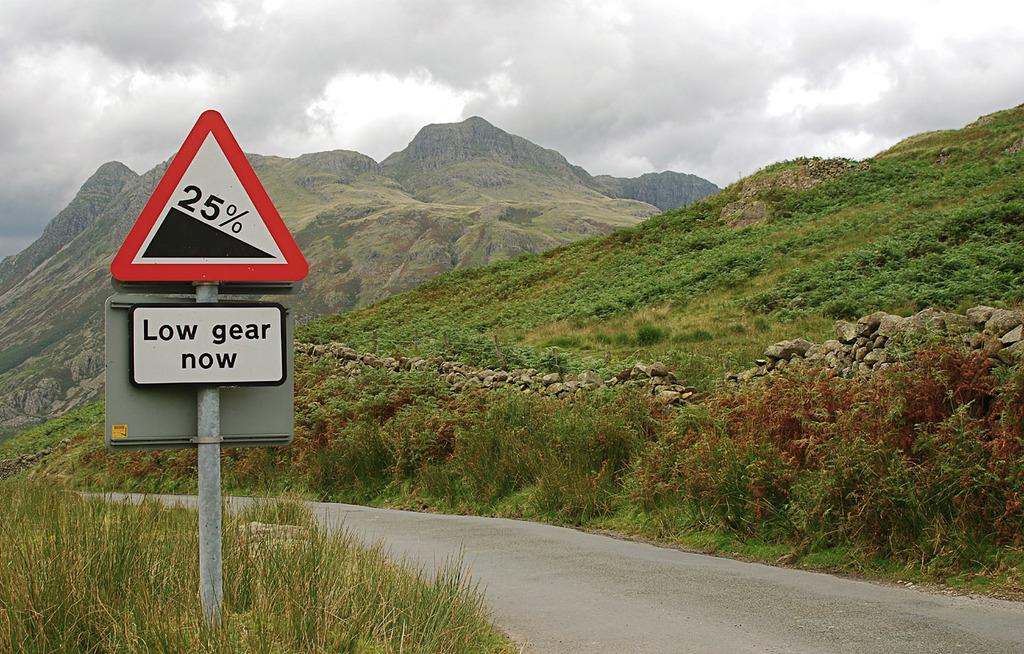<image>
Share a concise interpretation of the image provided. Low gear now sign on the side of the road in the grass 